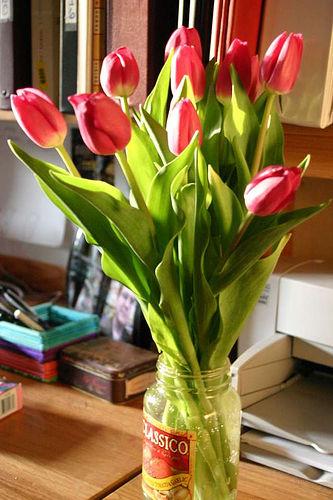What kind of flowers?
Be succinct. Tulips. Why did they get flowers?
Give a very brief answer. Anniversary. How many flowers are there?
Quick response, please. 9. 